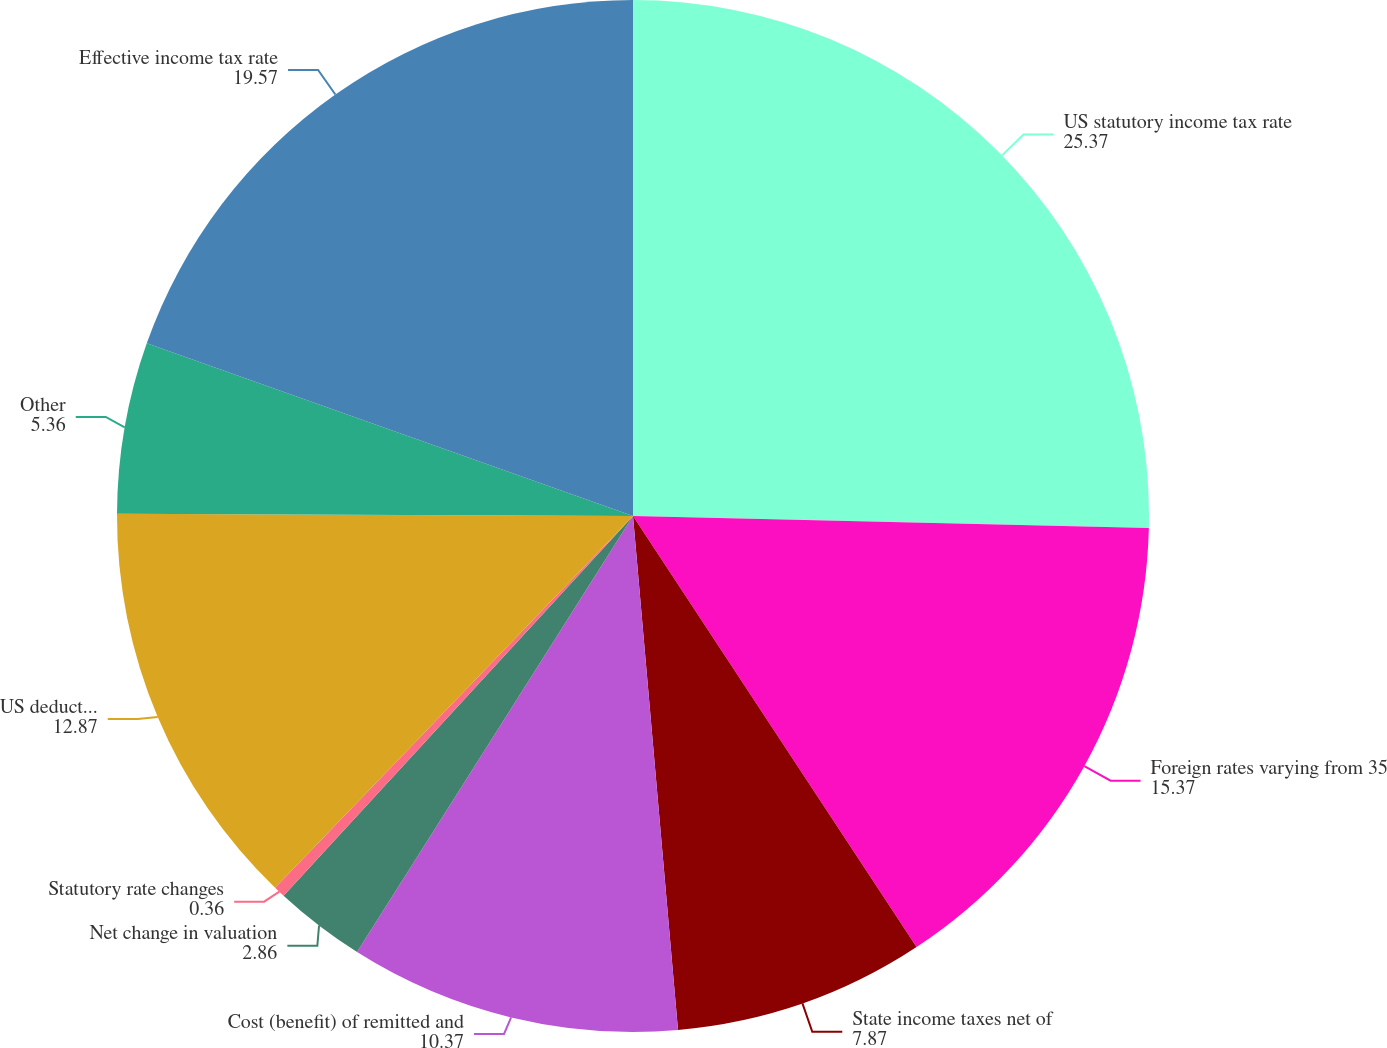<chart> <loc_0><loc_0><loc_500><loc_500><pie_chart><fcel>US statutory income tax rate<fcel>Foreign rates varying from 35<fcel>State income taxes net of<fcel>Cost (benefit) of remitted and<fcel>Net change in valuation<fcel>Statutory rate changes<fcel>US deduction for qualified<fcel>Other<fcel>Effective income tax rate<nl><fcel>25.37%<fcel>15.37%<fcel>7.87%<fcel>10.37%<fcel>2.86%<fcel>0.36%<fcel>12.87%<fcel>5.36%<fcel>19.57%<nl></chart> 